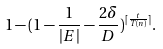Convert formula to latex. <formula><loc_0><loc_0><loc_500><loc_500>1 - ( 1 - \frac { 1 } { | E | } - \frac { 2 \delta } { D } ) ^ { \lceil \frac { t } { T ( n ) } \rceil } .</formula> 